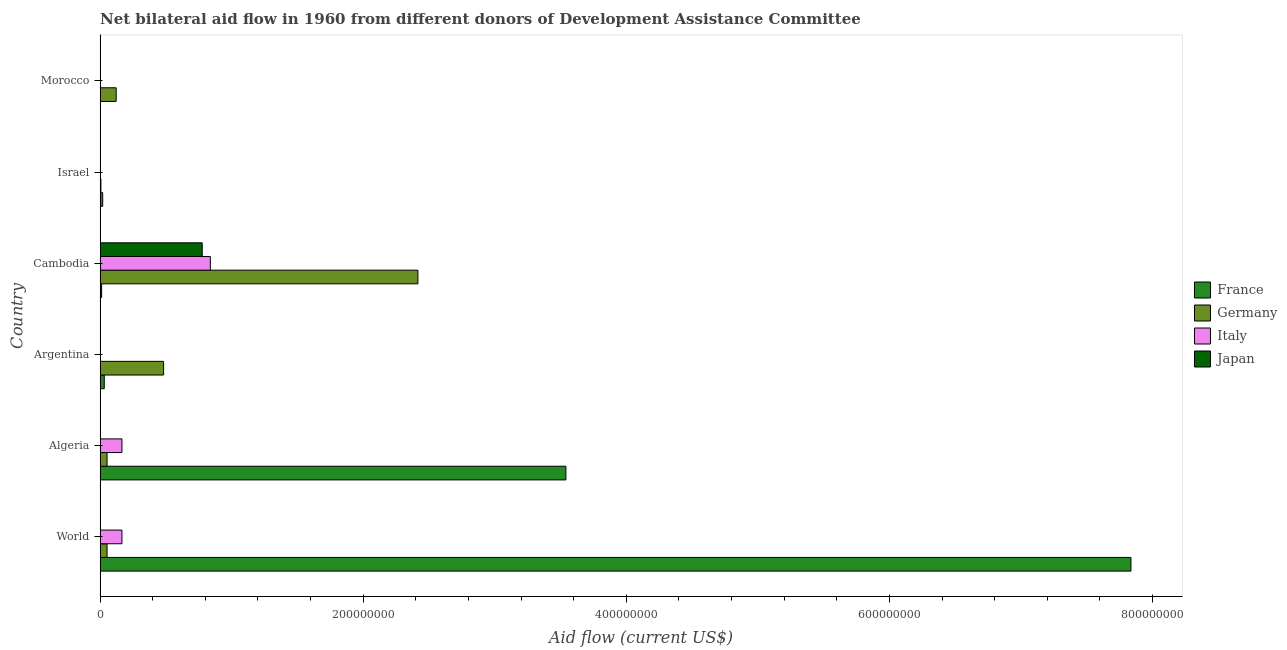How many different coloured bars are there?
Offer a terse response. 4. Are the number of bars per tick equal to the number of legend labels?
Your response must be concise. No. What is the label of the 5th group of bars from the top?
Keep it short and to the point. Algeria. In how many cases, is the number of bars for a given country not equal to the number of legend labels?
Ensure brevity in your answer.  2. What is the amount of aid given by germany in Cambodia?
Keep it short and to the point. 2.42e+08. Across all countries, what is the maximum amount of aid given by germany?
Give a very brief answer. 2.42e+08. Across all countries, what is the minimum amount of aid given by italy?
Your answer should be compact. 0. In which country was the amount of aid given by germany maximum?
Offer a terse response. Cambodia. What is the total amount of aid given by germany in the graph?
Your response must be concise. 3.13e+08. What is the difference between the amount of aid given by germany in Cambodia and that in Morocco?
Keep it short and to the point. 2.29e+08. What is the difference between the amount of aid given by italy in Argentina and the amount of aid given by japan in Israel?
Offer a terse response. -10000. What is the average amount of aid given by italy per country?
Ensure brevity in your answer.  1.95e+07. What is the difference between the amount of aid given by japan and amount of aid given by italy in Israel?
Offer a very short reply. 0. What is the ratio of the amount of aid given by germany in Algeria to that in Morocco?
Give a very brief answer. 0.43. What is the difference between the highest and the second highest amount of aid given by france?
Provide a short and direct response. 4.30e+08. What is the difference between the highest and the lowest amount of aid given by germany?
Give a very brief answer. 2.41e+08. In how many countries, is the amount of aid given by italy greater than the average amount of aid given by italy taken over all countries?
Provide a succinct answer. 1. Is it the case that in every country, the sum of the amount of aid given by germany and amount of aid given by italy is greater than the sum of amount of aid given by japan and amount of aid given by france?
Your response must be concise. No. Are all the bars in the graph horizontal?
Offer a very short reply. Yes. How many countries are there in the graph?
Keep it short and to the point. 6. What is the difference between two consecutive major ticks on the X-axis?
Offer a terse response. 2.00e+08. How are the legend labels stacked?
Provide a succinct answer. Vertical. What is the title of the graph?
Your answer should be compact. Net bilateral aid flow in 1960 from different donors of Development Assistance Committee. What is the label or title of the Y-axis?
Offer a very short reply. Country. What is the Aid flow (current US$) of France in World?
Give a very brief answer. 7.84e+08. What is the Aid flow (current US$) in Germany in World?
Your response must be concise. 5.32e+06. What is the Aid flow (current US$) in Italy in World?
Your answer should be very brief. 1.66e+07. What is the Aid flow (current US$) of France in Algeria?
Keep it short and to the point. 3.54e+08. What is the Aid flow (current US$) in Germany in Algeria?
Make the answer very short. 5.32e+06. What is the Aid flow (current US$) in Italy in Algeria?
Your response must be concise. 1.66e+07. What is the Aid flow (current US$) of France in Argentina?
Ensure brevity in your answer.  3.20e+06. What is the Aid flow (current US$) in Germany in Argentina?
Your answer should be compact. 4.83e+07. What is the Aid flow (current US$) in Italy in Argentina?
Provide a succinct answer. 0. What is the Aid flow (current US$) in France in Cambodia?
Your answer should be very brief. 1.20e+06. What is the Aid flow (current US$) in Germany in Cambodia?
Give a very brief answer. 2.42e+08. What is the Aid flow (current US$) in Italy in Cambodia?
Offer a terse response. 8.38e+07. What is the Aid flow (current US$) of Japan in Cambodia?
Your answer should be compact. 7.77e+07. What is the Aid flow (current US$) in Germany in Israel?
Provide a short and direct response. 6.50e+05. What is the Aid flow (current US$) in France in Morocco?
Your answer should be compact. 0. What is the Aid flow (current US$) of Germany in Morocco?
Offer a very short reply. 1.23e+07. What is the Aid flow (current US$) of Italy in Morocco?
Your answer should be compact. 0. What is the Aid flow (current US$) of Japan in Morocco?
Provide a succinct answer. 0. Across all countries, what is the maximum Aid flow (current US$) in France?
Offer a very short reply. 7.84e+08. Across all countries, what is the maximum Aid flow (current US$) of Germany?
Offer a terse response. 2.42e+08. Across all countries, what is the maximum Aid flow (current US$) in Italy?
Offer a very short reply. 8.38e+07. Across all countries, what is the maximum Aid flow (current US$) of Japan?
Make the answer very short. 7.77e+07. Across all countries, what is the minimum Aid flow (current US$) in Germany?
Make the answer very short. 6.50e+05. Across all countries, what is the minimum Aid flow (current US$) of Japan?
Provide a short and direct response. 0. What is the total Aid flow (current US$) of France in the graph?
Your answer should be very brief. 1.14e+09. What is the total Aid flow (current US$) of Germany in the graph?
Make the answer very short. 3.13e+08. What is the total Aid flow (current US$) in Italy in the graph?
Ensure brevity in your answer.  1.17e+08. What is the total Aid flow (current US$) of Japan in the graph?
Keep it short and to the point. 7.77e+07. What is the difference between the Aid flow (current US$) in France in World and that in Algeria?
Give a very brief answer. 4.30e+08. What is the difference between the Aid flow (current US$) of Germany in World and that in Algeria?
Offer a very short reply. 0. What is the difference between the Aid flow (current US$) in Italy in World and that in Algeria?
Your response must be concise. 0. What is the difference between the Aid flow (current US$) of France in World and that in Argentina?
Your answer should be very brief. 7.80e+08. What is the difference between the Aid flow (current US$) in Germany in World and that in Argentina?
Your answer should be very brief. -4.30e+07. What is the difference between the Aid flow (current US$) in France in World and that in Cambodia?
Make the answer very short. 7.82e+08. What is the difference between the Aid flow (current US$) in Germany in World and that in Cambodia?
Your answer should be very brief. -2.36e+08. What is the difference between the Aid flow (current US$) of Italy in World and that in Cambodia?
Provide a succinct answer. -6.72e+07. What is the difference between the Aid flow (current US$) of Japan in World and that in Cambodia?
Your answer should be very brief. -7.76e+07. What is the difference between the Aid flow (current US$) in France in World and that in Israel?
Provide a short and direct response. 7.82e+08. What is the difference between the Aid flow (current US$) in Germany in World and that in Israel?
Provide a succinct answer. 4.67e+06. What is the difference between the Aid flow (current US$) in Italy in World and that in Israel?
Give a very brief answer. 1.66e+07. What is the difference between the Aid flow (current US$) in Germany in World and that in Morocco?
Keep it short and to the point. -6.94e+06. What is the difference between the Aid flow (current US$) of France in Algeria and that in Argentina?
Keep it short and to the point. 3.51e+08. What is the difference between the Aid flow (current US$) in Germany in Algeria and that in Argentina?
Your answer should be compact. -4.30e+07. What is the difference between the Aid flow (current US$) of France in Algeria and that in Cambodia?
Provide a short and direct response. 3.53e+08. What is the difference between the Aid flow (current US$) of Germany in Algeria and that in Cambodia?
Provide a short and direct response. -2.36e+08. What is the difference between the Aid flow (current US$) of Italy in Algeria and that in Cambodia?
Offer a very short reply. -6.72e+07. What is the difference between the Aid flow (current US$) in Japan in Algeria and that in Cambodia?
Ensure brevity in your answer.  -7.76e+07. What is the difference between the Aid flow (current US$) of France in Algeria and that in Israel?
Give a very brief answer. 3.52e+08. What is the difference between the Aid flow (current US$) in Germany in Algeria and that in Israel?
Offer a very short reply. 4.67e+06. What is the difference between the Aid flow (current US$) in Italy in Algeria and that in Israel?
Make the answer very short. 1.66e+07. What is the difference between the Aid flow (current US$) in Germany in Algeria and that in Morocco?
Your response must be concise. -6.94e+06. What is the difference between the Aid flow (current US$) of Germany in Argentina and that in Cambodia?
Keep it short and to the point. -1.93e+08. What is the difference between the Aid flow (current US$) in France in Argentina and that in Israel?
Your answer should be compact. 1.20e+06. What is the difference between the Aid flow (current US$) in Germany in Argentina and that in Israel?
Provide a succinct answer. 4.76e+07. What is the difference between the Aid flow (current US$) of Germany in Argentina and that in Morocco?
Keep it short and to the point. 3.60e+07. What is the difference between the Aid flow (current US$) of France in Cambodia and that in Israel?
Give a very brief answer. -8.00e+05. What is the difference between the Aid flow (current US$) of Germany in Cambodia and that in Israel?
Your answer should be compact. 2.41e+08. What is the difference between the Aid flow (current US$) of Italy in Cambodia and that in Israel?
Provide a short and direct response. 8.38e+07. What is the difference between the Aid flow (current US$) of Japan in Cambodia and that in Israel?
Provide a short and direct response. 7.76e+07. What is the difference between the Aid flow (current US$) of Germany in Cambodia and that in Morocco?
Your response must be concise. 2.29e+08. What is the difference between the Aid flow (current US$) in Germany in Israel and that in Morocco?
Provide a succinct answer. -1.16e+07. What is the difference between the Aid flow (current US$) in France in World and the Aid flow (current US$) in Germany in Algeria?
Ensure brevity in your answer.  7.78e+08. What is the difference between the Aid flow (current US$) of France in World and the Aid flow (current US$) of Italy in Algeria?
Give a very brief answer. 7.67e+08. What is the difference between the Aid flow (current US$) in France in World and the Aid flow (current US$) in Japan in Algeria?
Make the answer very short. 7.84e+08. What is the difference between the Aid flow (current US$) in Germany in World and the Aid flow (current US$) in Italy in Algeria?
Ensure brevity in your answer.  -1.13e+07. What is the difference between the Aid flow (current US$) in Germany in World and the Aid flow (current US$) in Japan in Algeria?
Provide a succinct answer. 5.30e+06. What is the difference between the Aid flow (current US$) of Italy in World and the Aid flow (current US$) of Japan in Algeria?
Make the answer very short. 1.66e+07. What is the difference between the Aid flow (current US$) of France in World and the Aid flow (current US$) of Germany in Argentina?
Ensure brevity in your answer.  7.35e+08. What is the difference between the Aid flow (current US$) of France in World and the Aid flow (current US$) of Germany in Cambodia?
Keep it short and to the point. 5.42e+08. What is the difference between the Aid flow (current US$) of France in World and the Aid flow (current US$) of Italy in Cambodia?
Give a very brief answer. 7.00e+08. What is the difference between the Aid flow (current US$) of France in World and the Aid flow (current US$) of Japan in Cambodia?
Offer a very short reply. 7.06e+08. What is the difference between the Aid flow (current US$) in Germany in World and the Aid flow (current US$) in Italy in Cambodia?
Make the answer very short. -7.85e+07. What is the difference between the Aid flow (current US$) in Germany in World and the Aid flow (current US$) in Japan in Cambodia?
Give a very brief answer. -7.23e+07. What is the difference between the Aid flow (current US$) in Italy in World and the Aid flow (current US$) in Japan in Cambodia?
Your answer should be very brief. -6.10e+07. What is the difference between the Aid flow (current US$) in France in World and the Aid flow (current US$) in Germany in Israel?
Your answer should be very brief. 7.83e+08. What is the difference between the Aid flow (current US$) of France in World and the Aid flow (current US$) of Italy in Israel?
Keep it short and to the point. 7.84e+08. What is the difference between the Aid flow (current US$) in France in World and the Aid flow (current US$) in Japan in Israel?
Your response must be concise. 7.84e+08. What is the difference between the Aid flow (current US$) in Germany in World and the Aid flow (current US$) in Italy in Israel?
Keep it short and to the point. 5.31e+06. What is the difference between the Aid flow (current US$) of Germany in World and the Aid flow (current US$) of Japan in Israel?
Make the answer very short. 5.31e+06. What is the difference between the Aid flow (current US$) in Italy in World and the Aid flow (current US$) in Japan in Israel?
Your response must be concise. 1.66e+07. What is the difference between the Aid flow (current US$) of France in World and the Aid flow (current US$) of Germany in Morocco?
Keep it short and to the point. 7.71e+08. What is the difference between the Aid flow (current US$) of France in Algeria and the Aid flow (current US$) of Germany in Argentina?
Your answer should be compact. 3.06e+08. What is the difference between the Aid flow (current US$) in France in Algeria and the Aid flow (current US$) in Germany in Cambodia?
Give a very brief answer. 1.12e+08. What is the difference between the Aid flow (current US$) of France in Algeria and the Aid flow (current US$) of Italy in Cambodia?
Keep it short and to the point. 2.70e+08. What is the difference between the Aid flow (current US$) of France in Algeria and the Aid flow (current US$) of Japan in Cambodia?
Your answer should be compact. 2.76e+08. What is the difference between the Aid flow (current US$) of Germany in Algeria and the Aid flow (current US$) of Italy in Cambodia?
Ensure brevity in your answer.  -7.85e+07. What is the difference between the Aid flow (current US$) of Germany in Algeria and the Aid flow (current US$) of Japan in Cambodia?
Ensure brevity in your answer.  -7.23e+07. What is the difference between the Aid flow (current US$) of Italy in Algeria and the Aid flow (current US$) of Japan in Cambodia?
Your response must be concise. -6.10e+07. What is the difference between the Aid flow (current US$) of France in Algeria and the Aid flow (current US$) of Germany in Israel?
Your answer should be compact. 3.53e+08. What is the difference between the Aid flow (current US$) in France in Algeria and the Aid flow (current US$) in Italy in Israel?
Provide a short and direct response. 3.54e+08. What is the difference between the Aid flow (current US$) in France in Algeria and the Aid flow (current US$) in Japan in Israel?
Offer a terse response. 3.54e+08. What is the difference between the Aid flow (current US$) in Germany in Algeria and the Aid flow (current US$) in Italy in Israel?
Make the answer very short. 5.31e+06. What is the difference between the Aid flow (current US$) of Germany in Algeria and the Aid flow (current US$) of Japan in Israel?
Your answer should be very brief. 5.31e+06. What is the difference between the Aid flow (current US$) in Italy in Algeria and the Aid flow (current US$) in Japan in Israel?
Give a very brief answer. 1.66e+07. What is the difference between the Aid flow (current US$) of France in Algeria and the Aid flow (current US$) of Germany in Morocco?
Offer a very short reply. 3.42e+08. What is the difference between the Aid flow (current US$) in France in Argentina and the Aid flow (current US$) in Germany in Cambodia?
Provide a short and direct response. -2.38e+08. What is the difference between the Aid flow (current US$) in France in Argentina and the Aid flow (current US$) in Italy in Cambodia?
Make the answer very short. -8.06e+07. What is the difference between the Aid flow (current US$) of France in Argentina and the Aid flow (current US$) of Japan in Cambodia?
Provide a succinct answer. -7.45e+07. What is the difference between the Aid flow (current US$) in Germany in Argentina and the Aid flow (current US$) in Italy in Cambodia?
Keep it short and to the point. -3.55e+07. What is the difference between the Aid flow (current US$) in Germany in Argentina and the Aid flow (current US$) in Japan in Cambodia?
Provide a short and direct response. -2.94e+07. What is the difference between the Aid flow (current US$) of France in Argentina and the Aid flow (current US$) of Germany in Israel?
Offer a terse response. 2.55e+06. What is the difference between the Aid flow (current US$) of France in Argentina and the Aid flow (current US$) of Italy in Israel?
Offer a terse response. 3.19e+06. What is the difference between the Aid flow (current US$) in France in Argentina and the Aid flow (current US$) in Japan in Israel?
Your answer should be very brief. 3.19e+06. What is the difference between the Aid flow (current US$) of Germany in Argentina and the Aid flow (current US$) of Italy in Israel?
Provide a succinct answer. 4.83e+07. What is the difference between the Aid flow (current US$) in Germany in Argentina and the Aid flow (current US$) in Japan in Israel?
Offer a terse response. 4.83e+07. What is the difference between the Aid flow (current US$) in France in Argentina and the Aid flow (current US$) in Germany in Morocco?
Ensure brevity in your answer.  -9.06e+06. What is the difference between the Aid flow (current US$) in France in Cambodia and the Aid flow (current US$) in Germany in Israel?
Your response must be concise. 5.50e+05. What is the difference between the Aid flow (current US$) of France in Cambodia and the Aid flow (current US$) of Italy in Israel?
Offer a terse response. 1.19e+06. What is the difference between the Aid flow (current US$) in France in Cambodia and the Aid flow (current US$) in Japan in Israel?
Offer a very short reply. 1.19e+06. What is the difference between the Aid flow (current US$) in Germany in Cambodia and the Aid flow (current US$) in Italy in Israel?
Your answer should be compact. 2.42e+08. What is the difference between the Aid flow (current US$) in Germany in Cambodia and the Aid flow (current US$) in Japan in Israel?
Your response must be concise. 2.42e+08. What is the difference between the Aid flow (current US$) in Italy in Cambodia and the Aid flow (current US$) in Japan in Israel?
Your response must be concise. 8.38e+07. What is the difference between the Aid flow (current US$) of France in Cambodia and the Aid flow (current US$) of Germany in Morocco?
Make the answer very short. -1.11e+07. What is the difference between the Aid flow (current US$) of France in Israel and the Aid flow (current US$) of Germany in Morocco?
Provide a succinct answer. -1.03e+07. What is the average Aid flow (current US$) in France per country?
Offer a very short reply. 1.91e+08. What is the average Aid flow (current US$) of Germany per country?
Provide a short and direct response. 5.22e+07. What is the average Aid flow (current US$) in Italy per country?
Provide a short and direct response. 1.95e+07. What is the average Aid flow (current US$) in Japan per country?
Provide a short and direct response. 1.30e+07. What is the difference between the Aid flow (current US$) of France and Aid flow (current US$) of Germany in World?
Provide a succinct answer. 7.78e+08. What is the difference between the Aid flow (current US$) in France and Aid flow (current US$) in Italy in World?
Keep it short and to the point. 7.67e+08. What is the difference between the Aid flow (current US$) in France and Aid flow (current US$) in Japan in World?
Offer a very short reply. 7.84e+08. What is the difference between the Aid flow (current US$) of Germany and Aid flow (current US$) of Italy in World?
Keep it short and to the point. -1.13e+07. What is the difference between the Aid flow (current US$) in Germany and Aid flow (current US$) in Japan in World?
Provide a succinct answer. 5.30e+06. What is the difference between the Aid flow (current US$) of Italy and Aid flow (current US$) of Japan in World?
Your answer should be very brief. 1.66e+07. What is the difference between the Aid flow (current US$) of France and Aid flow (current US$) of Germany in Algeria?
Offer a terse response. 3.49e+08. What is the difference between the Aid flow (current US$) of France and Aid flow (current US$) of Italy in Algeria?
Your response must be concise. 3.37e+08. What is the difference between the Aid flow (current US$) of France and Aid flow (current US$) of Japan in Algeria?
Make the answer very short. 3.54e+08. What is the difference between the Aid flow (current US$) of Germany and Aid flow (current US$) of Italy in Algeria?
Make the answer very short. -1.13e+07. What is the difference between the Aid flow (current US$) of Germany and Aid flow (current US$) of Japan in Algeria?
Your answer should be very brief. 5.30e+06. What is the difference between the Aid flow (current US$) of Italy and Aid flow (current US$) of Japan in Algeria?
Make the answer very short. 1.66e+07. What is the difference between the Aid flow (current US$) of France and Aid flow (current US$) of Germany in Argentina?
Keep it short and to the point. -4.51e+07. What is the difference between the Aid flow (current US$) of France and Aid flow (current US$) of Germany in Cambodia?
Offer a terse response. -2.40e+08. What is the difference between the Aid flow (current US$) of France and Aid flow (current US$) of Italy in Cambodia?
Your response must be concise. -8.26e+07. What is the difference between the Aid flow (current US$) of France and Aid flow (current US$) of Japan in Cambodia?
Offer a terse response. -7.65e+07. What is the difference between the Aid flow (current US$) of Germany and Aid flow (current US$) of Italy in Cambodia?
Offer a very short reply. 1.58e+08. What is the difference between the Aid flow (current US$) in Germany and Aid flow (current US$) in Japan in Cambodia?
Offer a terse response. 1.64e+08. What is the difference between the Aid flow (current US$) of Italy and Aid flow (current US$) of Japan in Cambodia?
Offer a terse response. 6.17e+06. What is the difference between the Aid flow (current US$) in France and Aid flow (current US$) in Germany in Israel?
Your answer should be very brief. 1.35e+06. What is the difference between the Aid flow (current US$) of France and Aid flow (current US$) of Italy in Israel?
Give a very brief answer. 1.99e+06. What is the difference between the Aid flow (current US$) in France and Aid flow (current US$) in Japan in Israel?
Keep it short and to the point. 1.99e+06. What is the difference between the Aid flow (current US$) of Germany and Aid flow (current US$) of Italy in Israel?
Your answer should be compact. 6.40e+05. What is the difference between the Aid flow (current US$) of Germany and Aid flow (current US$) of Japan in Israel?
Your response must be concise. 6.40e+05. What is the ratio of the Aid flow (current US$) in France in World to that in Algeria?
Keep it short and to the point. 2.21. What is the ratio of the Aid flow (current US$) of Germany in World to that in Algeria?
Give a very brief answer. 1. What is the ratio of the Aid flow (current US$) of France in World to that in Argentina?
Keep it short and to the point. 244.88. What is the ratio of the Aid flow (current US$) of Germany in World to that in Argentina?
Provide a succinct answer. 0.11. What is the ratio of the Aid flow (current US$) of France in World to that in Cambodia?
Give a very brief answer. 653. What is the ratio of the Aid flow (current US$) of Germany in World to that in Cambodia?
Your response must be concise. 0.02. What is the ratio of the Aid flow (current US$) of Italy in World to that in Cambodia?
Offer a very short reply. 0.2. What is the ratio of the Aid flow (current US$) of Japan in World to that in Cambodia?
Give a very brief answer. 0. What is the ratio of the Aid flow (current US$) of France in World to that in Israel?
Offer a very short reply. 391.8. What is the ratio of the Aid flow (current US$) of Germany in World to that in Israel?
Your answer should be very brief. 8.18. What is the ratio of the Aid flow (current US$) of Italy in World to that in Israel?
Offer a very short reply. 1664. What is the ratio of the Aid flow (current US$) of Japan in World to that in Israel?
Your answer should be compact. 2. What is the ratio of the Aid flow (current US$) in Germany in World to that in Morocco?
Your response must be concise. 0.43. What is the ratio of the Aid flow (current US$) of France in Algeria to that in Argentina?
Offer a terse response. 110.66. What is the ratio of the Aid flow (current US$) in Germany in Algeria to that in Argentina?
Keep it short and to the point. 0.11. What is the ratio of the Aid flow (current US$) in France in Algeria to that in Cambodia?
Your answer should be compact. 295.08. What is the ratio of the Aid flow (current US$) in Germany in Algeria to that in Cambodia?
Keep it short and to the point. 0.02. What is the ratio of the Aid flow (current US$) in Italy in Algeria to that in Cambodia?
Your answer should be compact. 0.2. What is the ratio of the Aid flow (current US$) of France in Algeria to that in Israel?
Your response must be concise. 177.05. What is the ratio of the Aid flow (current US$) of Germany in Algeria to that in Israel?
Provide a succinct answer. 8.18. What is the ratio of the Aid flow (current US$) of Italy in Algeria to that in Israel?
Ensure brevity in your answer.  1664. What is the ratio of the Aid flow (current US$) of Japan in Algeria to that in Israel?
Ensure brevity in your answer.  2. What is the ratio of the Aid flow (current US$) of Germany in Algeria to that in Morocco?
Keep it short and to the point. 0.43. What is the ratio of the Aid flow (current US$) of France in Argentina to that in Cambodia?
Your answer should be compact. 2.67. What is the ratio of the Aid flow (current US$) of Germany in Argentina to that in Cambodia?
Your response must be concise. 0.2. What is the ratio of the Aid flow (current US$) of Germany in Argentina to that in Israel?
Your answer should be compact. 74.29. What is the ratio of the Aid flow (current US$) in Germany in Argentina to that in Morocco?
Your response must be concise. 3.94. What is the ratio of the Aid flow (current US$) in Germany in Cambodia to that in Israel?
Ensure brevity in your answer.  371.71. What is the ratio of the Aid flow (current US$) of Italy in Cambodia to that in Israel?
Ensure brevity in your answer.  8383. What is the ratio of the Aid flow (current US$) of Japan in Cambodia to that in Israel?
Keep it short and to the point. 7766. What is the ratio of the Aid flow (current US$) in Germany in Cambodia to that in Morocco?
Your answer should be compact. 19.71. What is the ratio of the Aid flow (current US$) of Germany in Israel to that in Morocco?
Offer a very short reply. 0.05. What is the difference between the highest and the second highest Aid flow (current US$) of France?
Keep it short and to the point. 4.30e+08. What is the difference between the highest and the second highest Aid flow (current US$) in Germany?
Give a very brief answer. 1.93e+08. What is the difference between the highest and the second highest Aid flow (current US$) of Italy?
Give a very brief answer. 6.72e+07. What is the difference between the highest and the second highest Aid flow (current US$) of Japan?
Your answer should be very brief. 7.76e+07. What is the difference between the highest and the lowest Aid flow (current US$) of France?
Provide a succinct answer. 7.84e+08. What is the difference between the highest and the lowest Aid flow (current US$) in Germany?
Your answer should be very brief. 2.41e+08. What is the difference between the highest and the lowest Aid flow (current US$) of Italy?
Ensure brevity in your answer.  8.38e+07. What is the difference between the highest and the lowest Aid flow (current US$) of Japan?
Your response must be concise. 7.77e+07. 